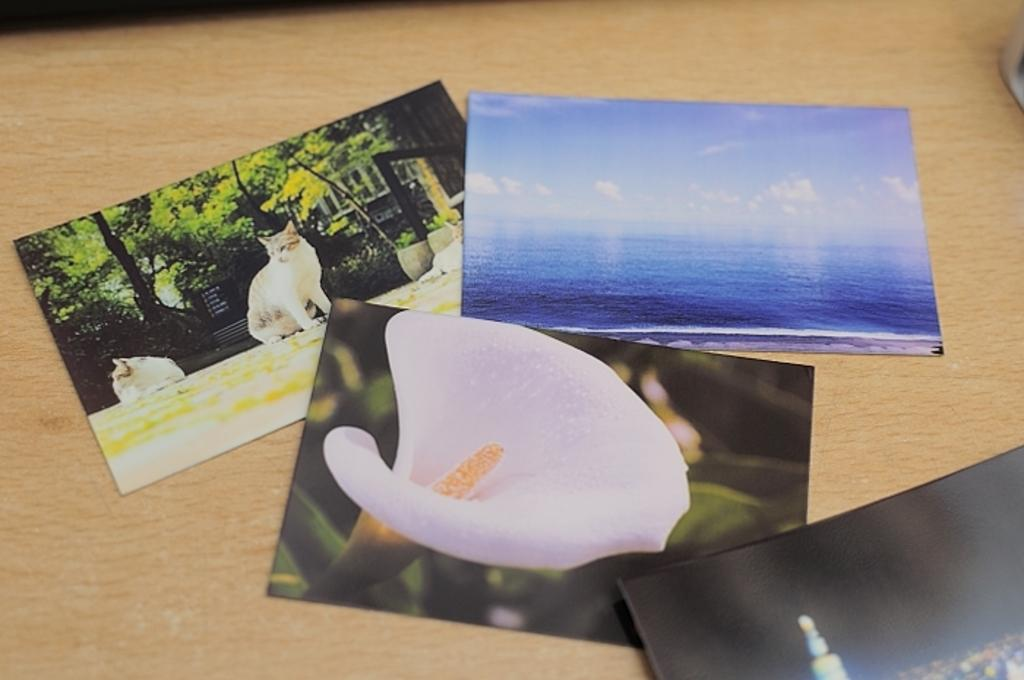What type of images can be seen in the photocopies in the image? There are photocopies of animals, a flower, water, and the sky in the image. What is the surface on which the photocopies are placed? The photocopies are placed on a wooden surface. Is there any other object visible in the image? Yes, there is an object on the right side of the image. What type of representative is attending the class in the image? There is no class or representative present in the image; it features photocopies of various images placed on a wooden surface. What type of business is being conducted in the image? There is no business being conducted in the image; it features photocopies of various images placed on a wooden surface. 